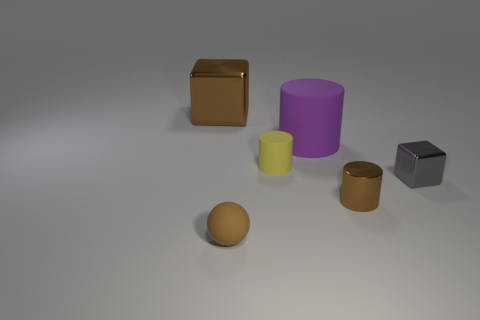Subtract all yellow cylinders. How many cylinders are left? 2 Add 2 small rubber objects. How many objects exist? 8 Subtract all brown blocks. How many blocks are left? 1 Subtract 1 spheres. How many spheres are left? 0 Add 6 tiny brown shiny things. How many tiny brown shiny things exist? 7 Subtract 0 cyan blocks. How many objects are left? 6 Subtract all blocks. How many objects are left? 4 Subtract all cyan spheres. Subtract all yellow cylinders. How many spheres are left? 1 Subtract all green blocks. How many red balls are left? 0 Subtract all big gray metal blocks. Subtract all purple matte things. How many objects are left? 5 